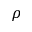Convert formula to latex. <formula><loc_0><loc_0><loc_500><loc_500>\rho</formula> 